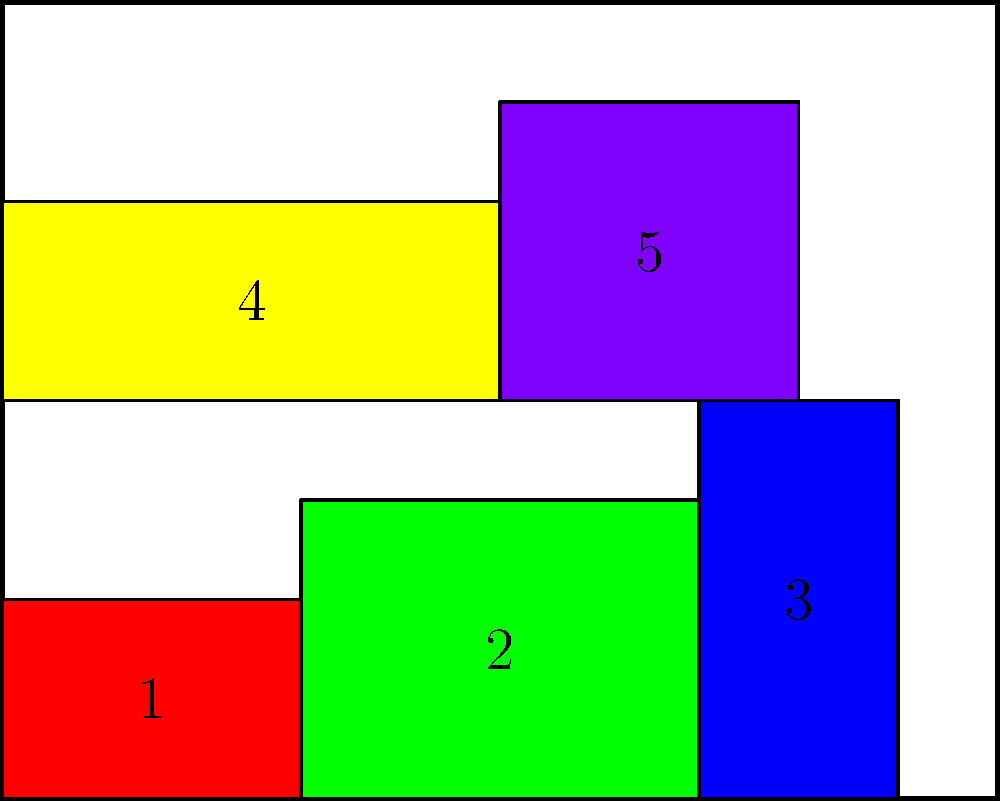A tech company is optimizing container placement on their servers using 2D bin packing. Given a server with dimensions 10x8 and five containers with dimensions (width x height) of 3x2, 4x3, 2x4, 5x2, and 3x3, what is the minimum height required to pack all containers on the server, assuming they can be placed side by side but not overlapping? Refer to the visualization for container arrangement. Let's approach this step-by-step:

1) First, we need to understand the constraints:
   - Server width is 10 units
   - Containers can be placed side by side but not overlapping
   - We need to minimize the height used

2) Looking at the container dimensions:
   - Container 1: 3x2
   - Container 2: 4x3
   - Container 3: 2x4
   - Container 4: 5x2
   - Container 5: 3x3

3) Optimal placement strategy:
   - Row 1: Place containers 1, 2, and 3 side by side
     * Total width: 3 + 4 + 2 = 9 ≤ 10
     * Height of this row: max(2, 3, 4) = 4

   - Row 2: Place containers 4 and 5 side by side
     * Total width: 5 + 3 = 8 ≤ 10
     * Height of this row: max(2, 3) = 3

4) Calculate total height:
   - Height of Row 1 + Height of Row 2
   - 4 + 3 = 7

Therefore, the minimum height required to pack all containers is 7 units.
Answer: 7 units 